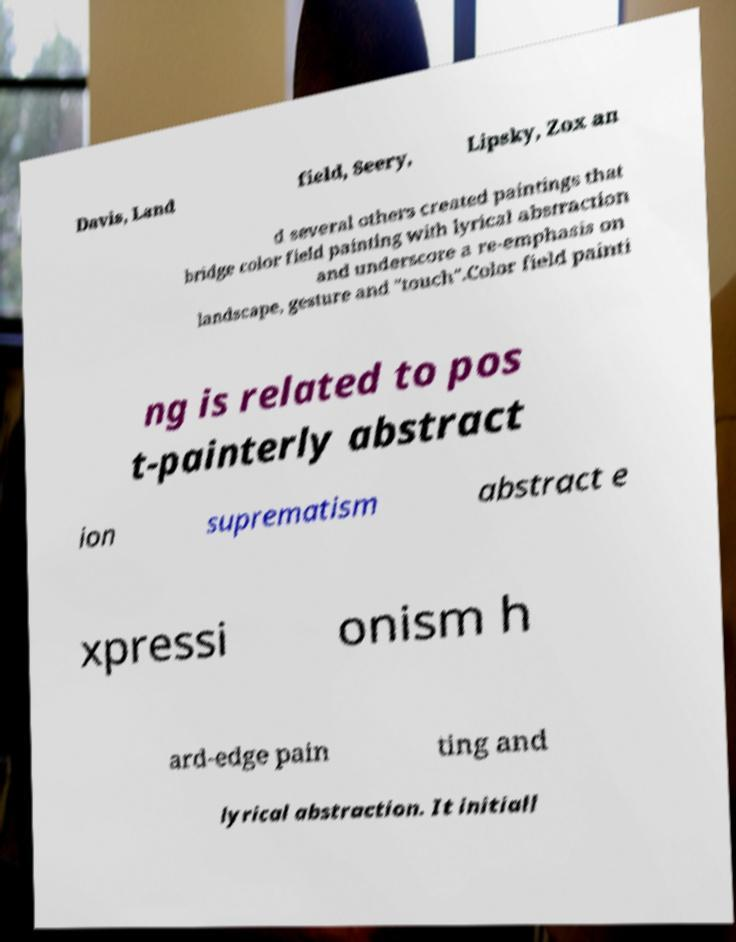For documentation purposes, I need the text within this image transcribed. Could you provide that? Davis, Land field, Seery, Lipsky, Zox an d several others created paintings that bridge color field painting with lyrical abstraction and underscore a re-emphasis on landscape, gesture and "touch".Color field painti ng is related to pos t-painterly abstract ion suprematism abstract e xpressi onism h ard-edge pain ting and lyrical abstraction. It initiall 